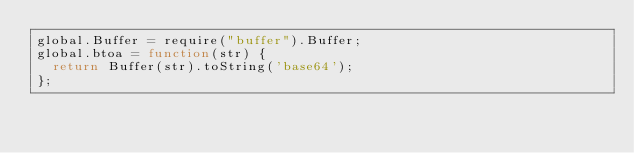<code> <loc_0><loc_0><loc_500><loc_500><_JavaScript_>global.Buffer = require("buffer").Buffer;
global.btoa = function(str) {
  return Buffer(str).toString('base64');
};
</code> 